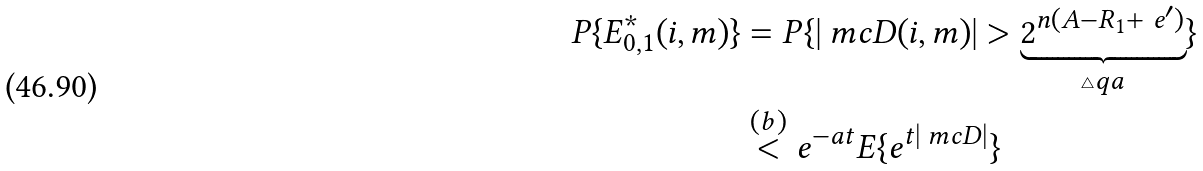<formula> <loc_0><loc_0><loc_500><loc_500>P \{ E _ { 0 , 1 } ^ { * } ( i , m ) \} & = P \{ | \ m c { D } ( i , m ) | > \underbrace { 2 ^ { n ( A - R _ { 1 } + \ e ^ { \prime } ) } } _ { \triangle q a } \} \\ & \overset { ( b ) } { < } e ^ { - a t } E \{ e ^ { t | \ m c { D } | } \}</formula> 